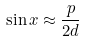<formula> <loc_0><loc_0><loc_500><loc_500>\sin x \approx \frac { p } { 2 d }</formula> 